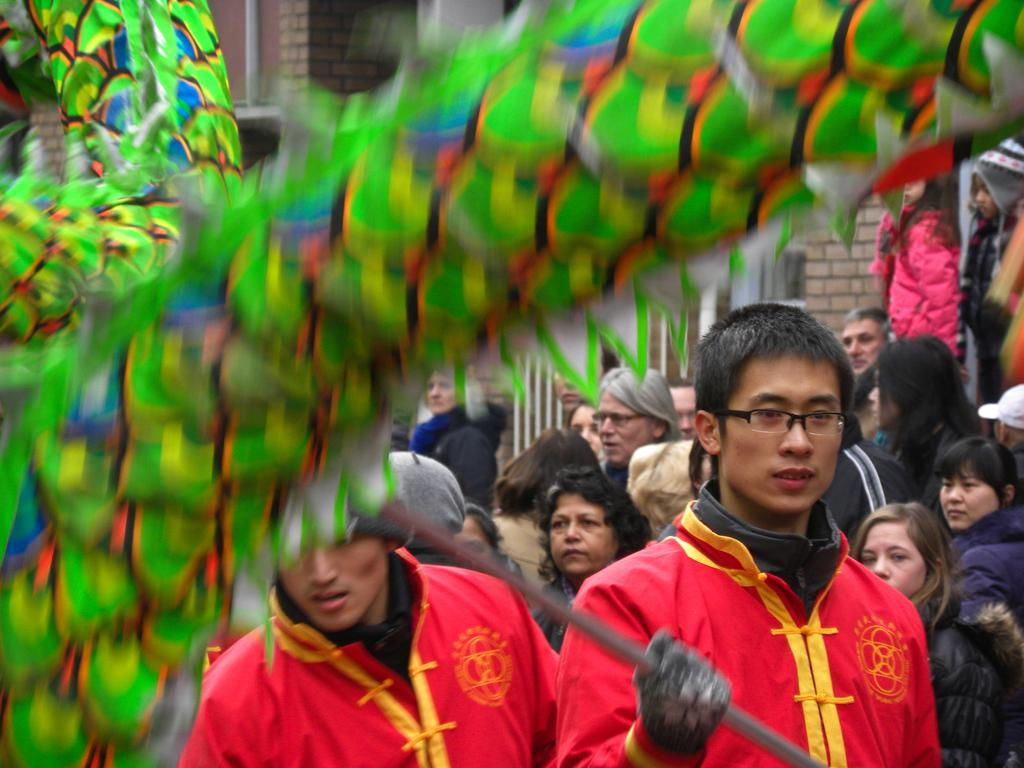What color is the object in the image? The object in the image is green. Can you describe the people in the image? There are people in the image, but their specific characteristics are not mentioned in the facts. What is the person holding in the image? The person is holding a rod in the image. What type of structure can be seen in the image? There are brick walls in the image. What type of feather can be seen on the person's hat in the image? There is no mention of a hat or feather in the image, so we cannot answer this question. 